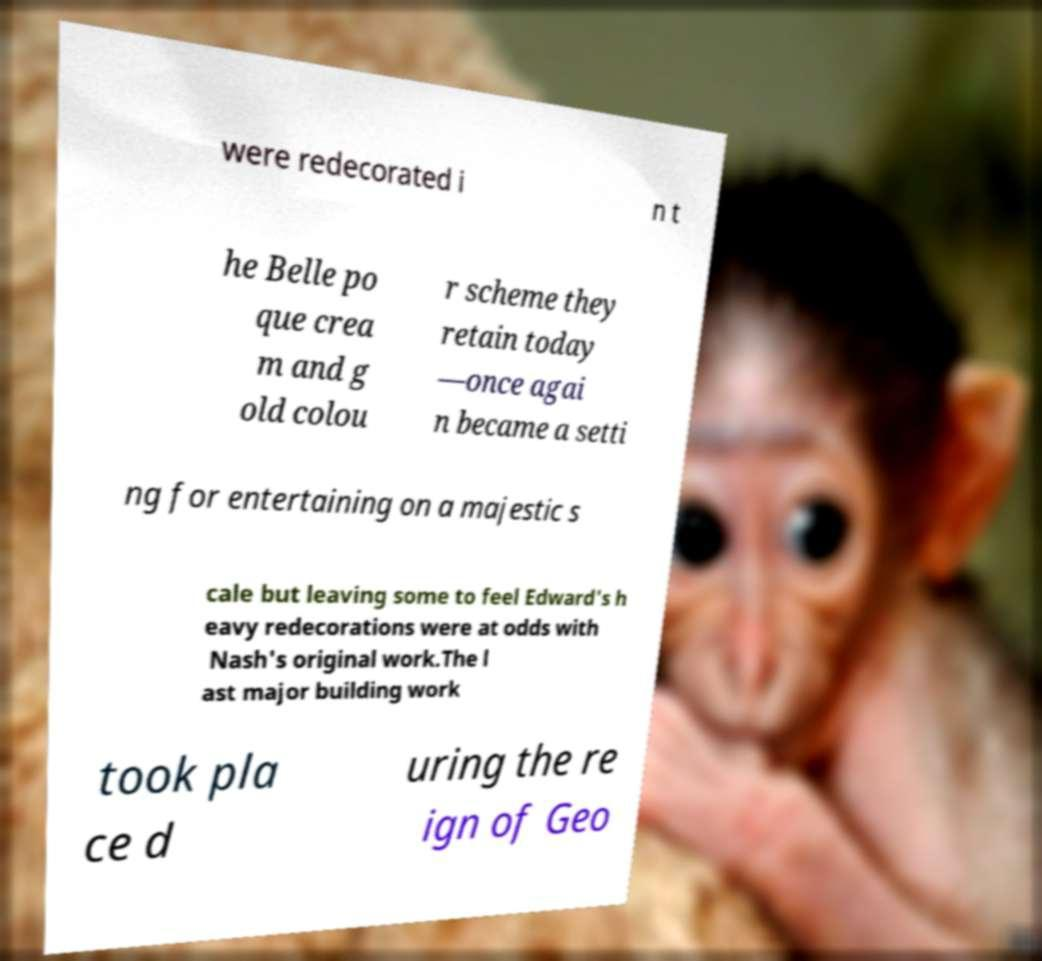What messages or text are displayed in this image? I need them in a readable, typed format. were redecorated i n t he Belle po que crea m and g old colou r scheme they retain today —once agai n became a setti ng for entertaining on a majestic s cale but leaving some to feel Edward's h eavy redecorations were at odds with Nash's original work.The l ast major building work took pla ce d uring the re ign of Geo 